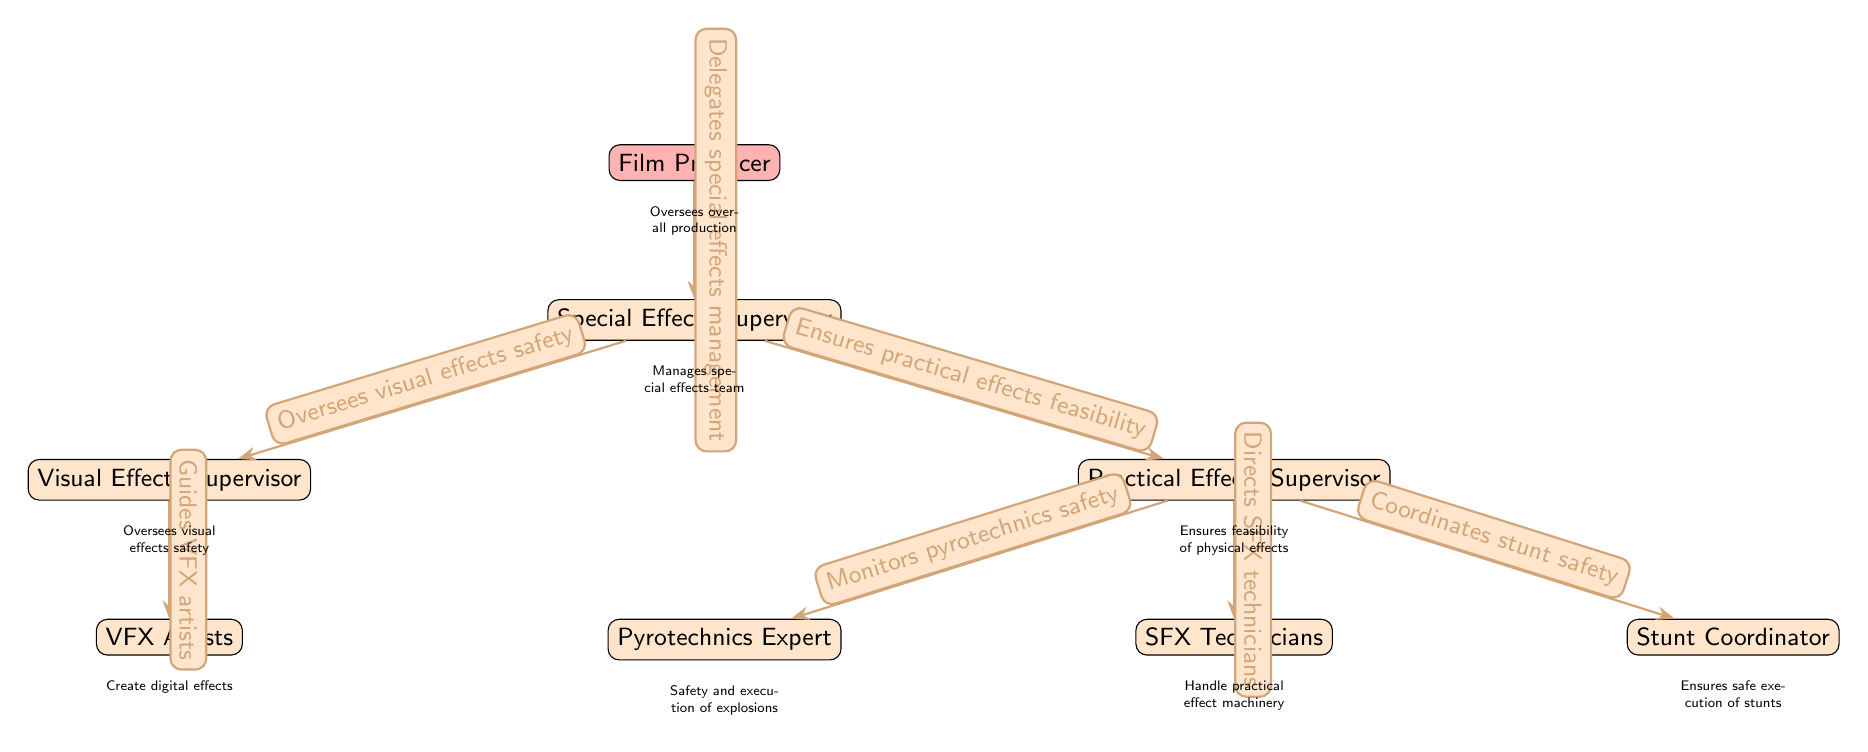What is the top node in the diagram? The top node represents the Film Producer, who oversees the overall production.
Answer: Film Producer How many levels are there in the hierarchy? There are two main levels in the hierarchy: the first level is the Film Producer, and the second level consists of the Special Effects Supervisor and the Visual and Practical Effects Supervisors.
Answer: 2 What is the role of the Practical Effects Supervisor? The role of the Practical Effects Supervisor is to ensure the feasibility of physical effects used in the production.
Answer: Ensures feasibility of physical effects How many teams report directly to the Special Effects Supervisor? The Special Effects Supervisor has two teams reporting directly: the Visual Effects Supervisor and the Practical Effects Supervisor.
Answer: 2 What is the relationship between the Practical Effects Supervisor and the Stunt Coordinator? The Stunt Coordinator is a part of the Practical Effects Supervisor's team, specifically responsible for coordinating stunt safety measures.
Answer: Coordinates stunt safety How does the Visual Effects Supervisor contribute to safety? The Visual Effects Supervisor contributes to safety by overseeing visual effects safety, ensuring that the digital effects created do not pose any hazards.
Answer: Oversees visual effects safety What are the two primary types of effects mentioned in the diagram? The two primary types of effects mentioned are visual effects and practical effects.
Answer: Visual and Practical Effects What specific safety role does the Pyrotechnics Expert have? The Pyrotechnics Expert is responsible for monitoring the safety and execution of explosions during filming.
Answer: Monitors pyrotechnics safety Which team is responsible for creating digital effects? The team responsible for creating digital effects is comprised of VFX Artists who work under the guidance of the Visual Effects Supervisor.
Answer: VFX Artists 